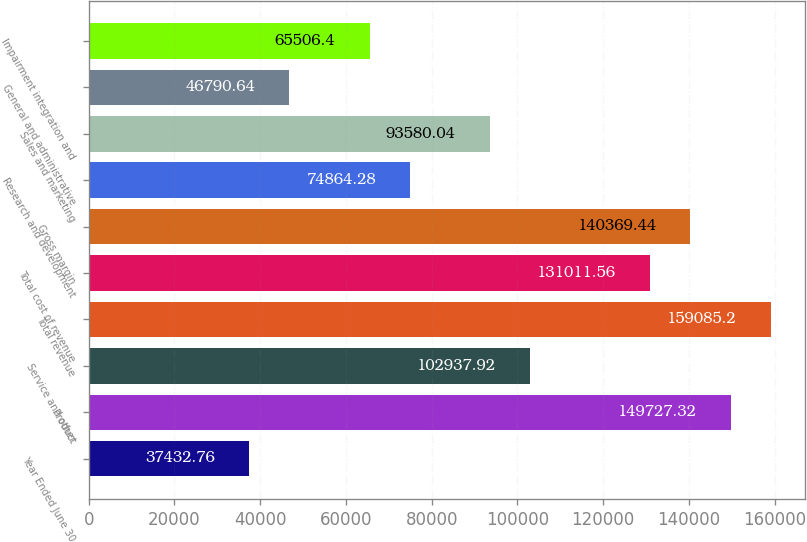<chart> <loc_0><loc_0><loc_500><loc_500><bar_chart><fcel>Year Ended June 30<fcel>Product<fcel>Service and other<fcel>Total revenue<fcel>Total cost of revenue<fcel>Gross margin<fcel>Research and development<fcel>Sales and marketing<fcel>General and administrative<fcel>Impairment integration and<nl><fcel>37432.8<fcel>149727<fcel>102938<fcel>159085<fcel>131012<fcel>140369<fcel>74864.3<fcel>93580<fcel>46790.6<fcel>65506.4<nl></chart> 